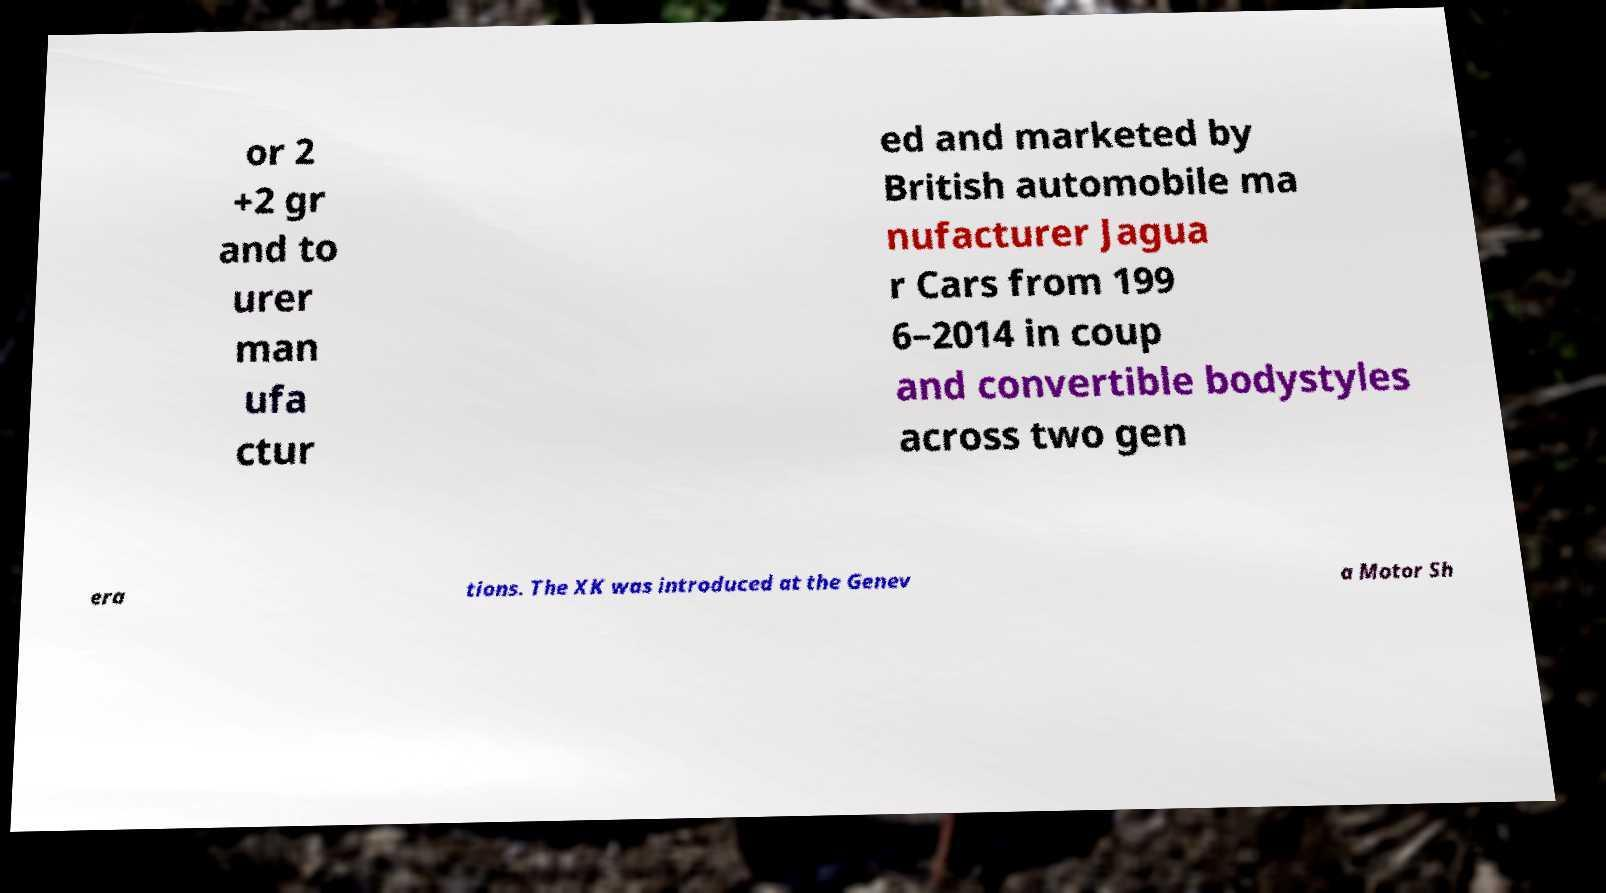What messages or text are displayed in this image? I need them in a readable, typed format. or 2 +2 gr and to urer man ufa ctur ed and marketed by British automobile ma nufacturer Jagua r Cars from 199 6–2014 in coup and convertible bodystyles across two gen era tions. The XK was introduced at the Genev a Motor Sh 